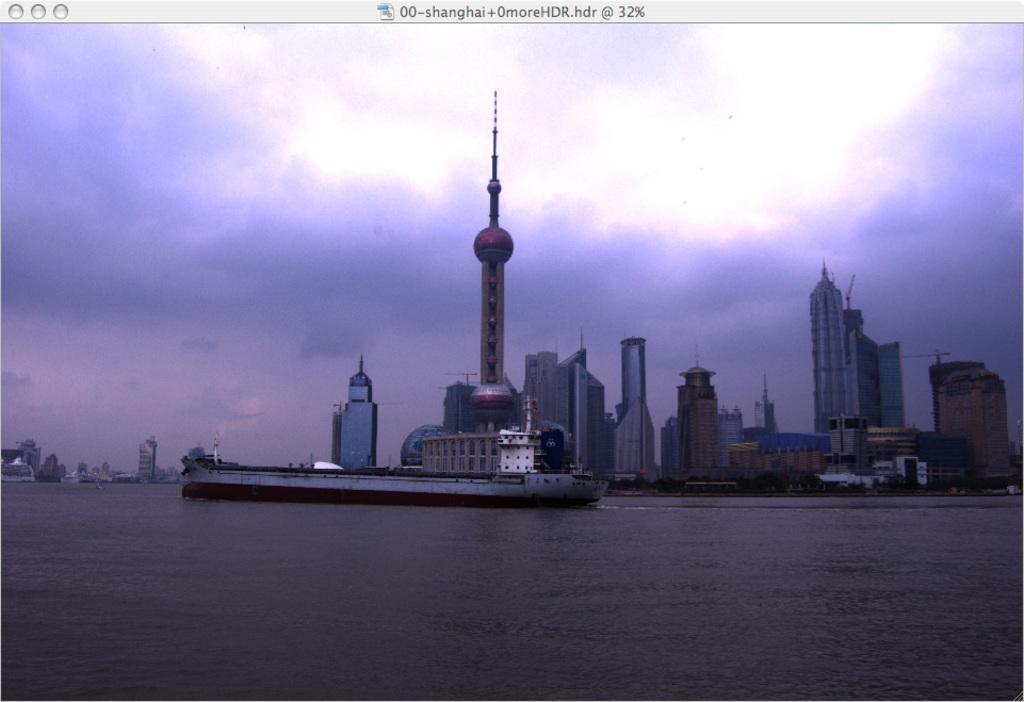Can you describe this image briefly? In this picture I can see the water in front on which there is a boat. In the background I can see the buildings and I see the sky which is cloudy. On the top of this picture I can see something is written. 